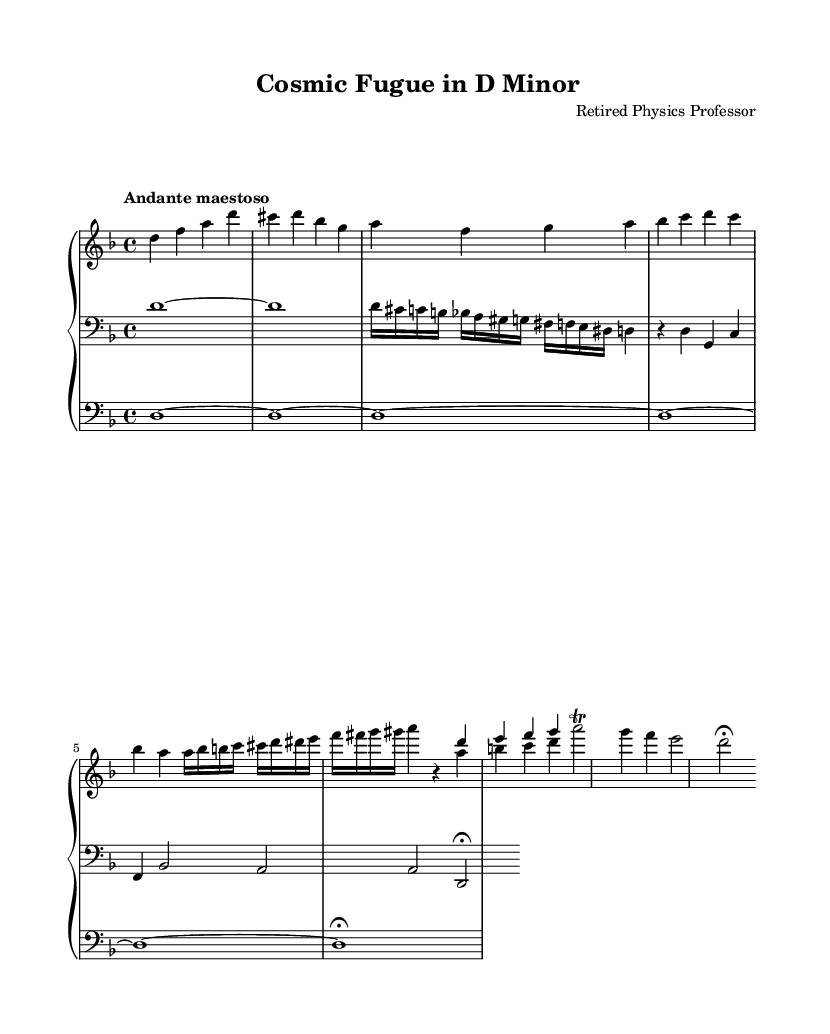What is the key signature of this music? The key signature is derived from the key specified at the beginning of the music score. In this case, it's indicated by "\key d \minor", which means two flats: B flat and E flat.
Answer: D minor What is the time signature of this music? The time signature is shown at the beginning of the music score with "\time 4/4". In this case, it means there are four beats in a measure, and each quarter note gets one beat.
Answer: 4/4 What is the tempo marking of this piece? The tempo marking is usually found near the beginning of the score. Here, "Andante maestoso" indicates a moderately slow tempo that conveys a stately or majestic character.
Answer: Andante maestoso How many measures are there in the right-hand part? To determine the number of measures, we count the number of times a vertical line appears, marking the end of each measure. The right hand section contains 6 measures in total.
Answer: 6 Which musical techniques are employed in this piece? By examining the musical notations, we can identify various techniques such as counterpoint (the simultaneous use of two or more melodies) and trills. The score exhibits a complex counterpoint with interwoven themes.
Answer: Counterpoint and trills What is the highest pitch note in the right-hand part? In the right-hand section, we analyze the notes and locate the highest pitch in the staff. The note 'g' in the fourth measure of the right hand is the highest note.
Answer: g What type of music form is primarily used in this piece? By analyzing the structure of the piece, particularly the use of themes and variations in musical lines, we can see that this is indicative of a fugue, a common compositional technique utilized in Baroque music.
Answer: Fugue 